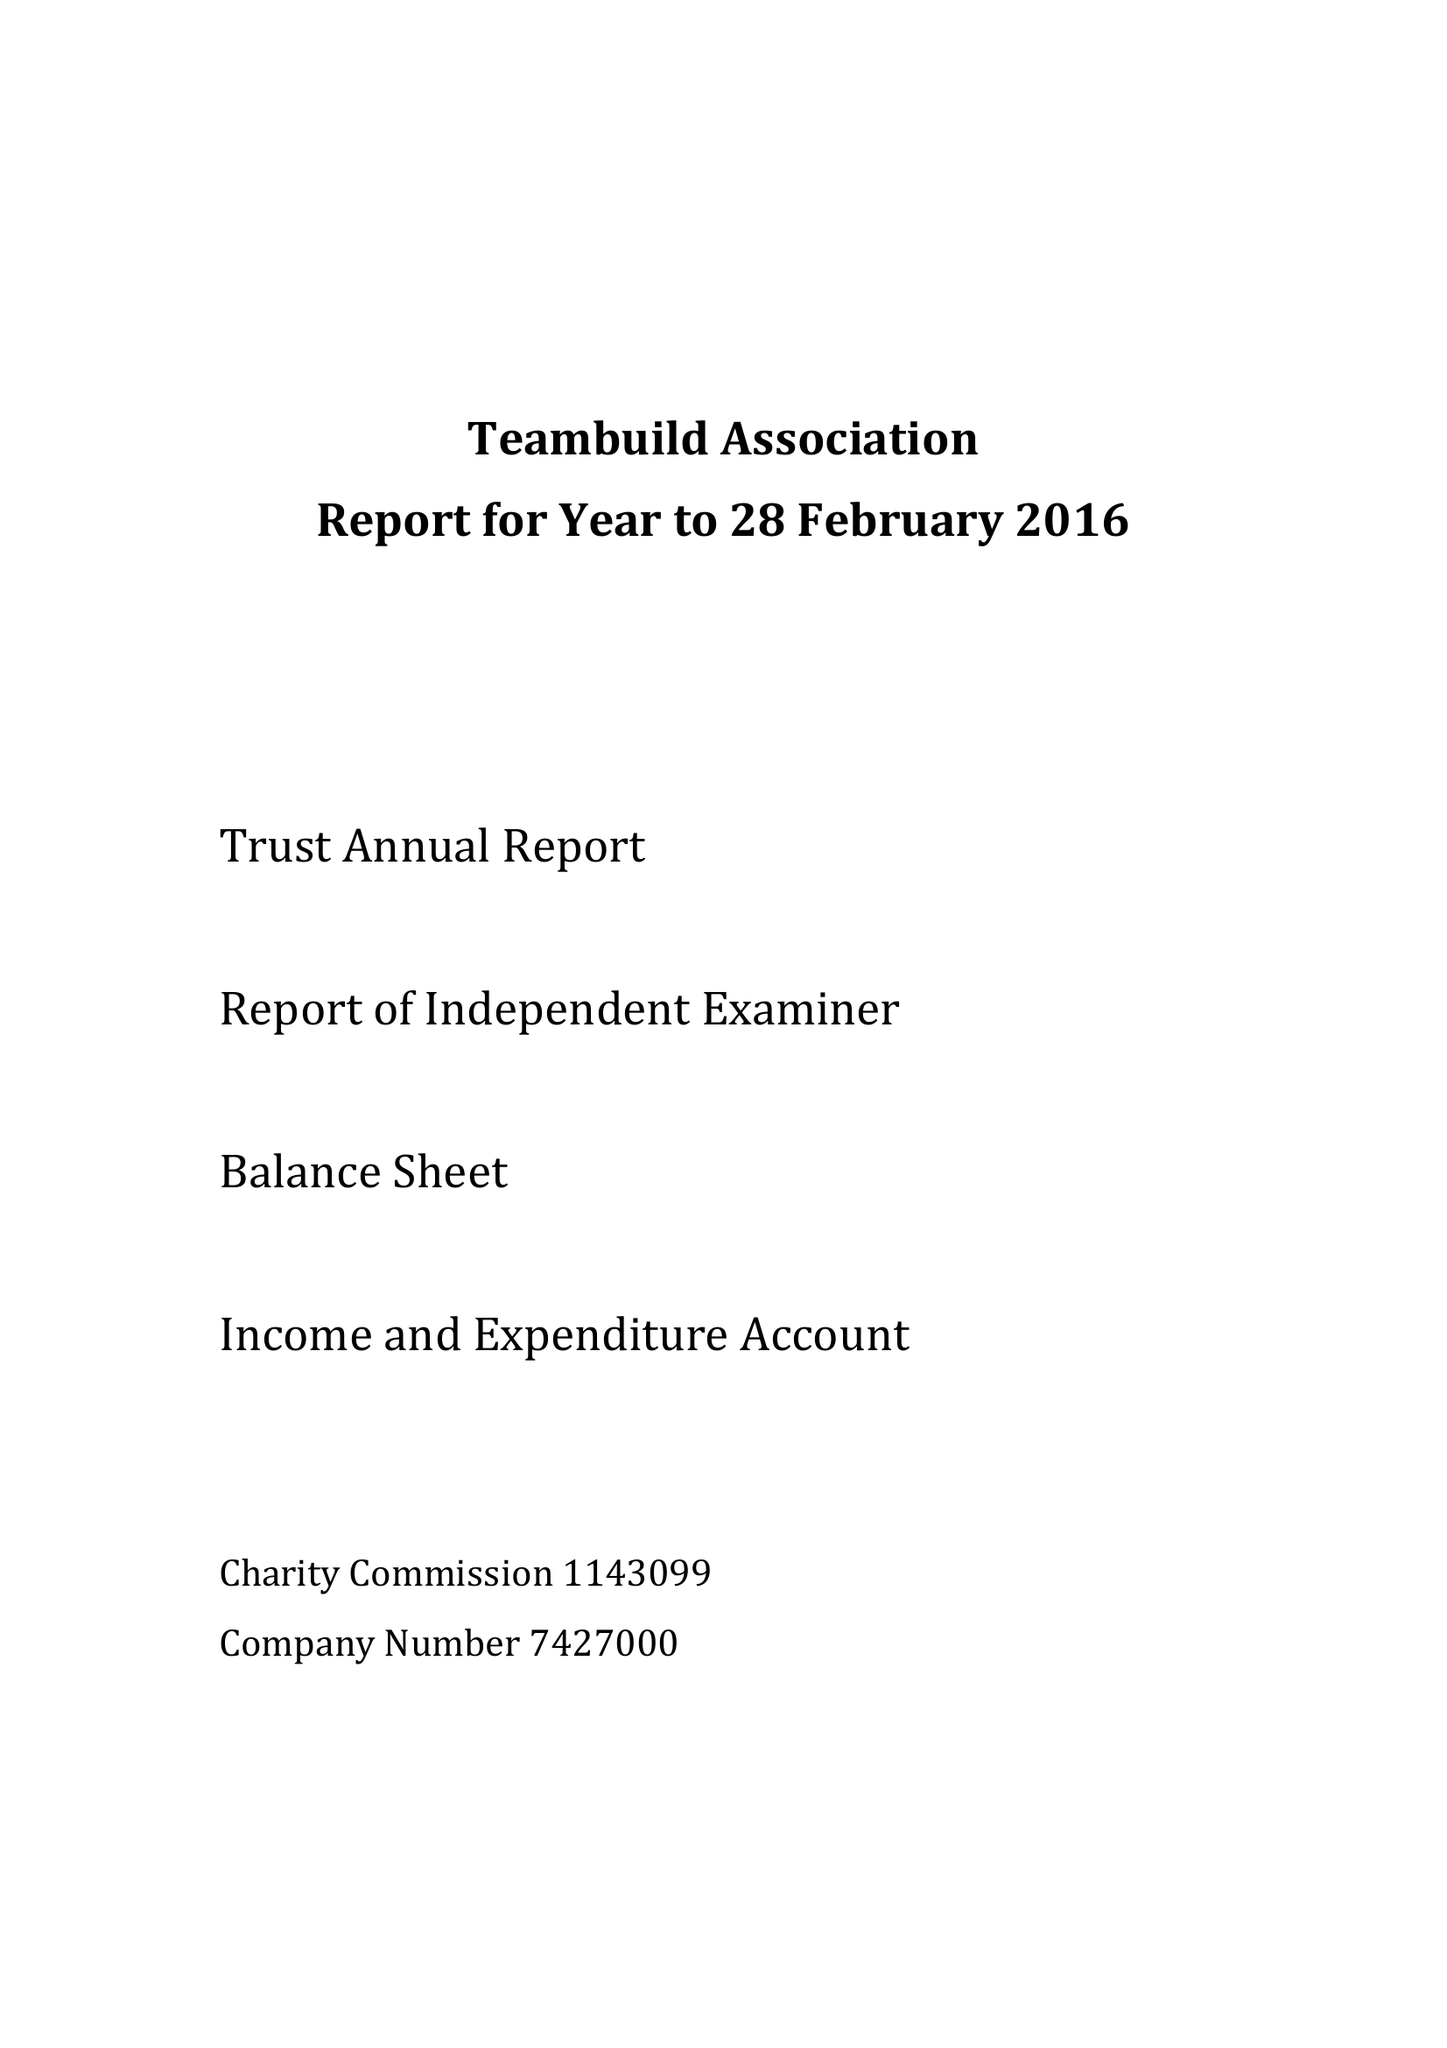What is the value for the address__post_town?
Answer the question using a single word or phrase. SLOUGH 